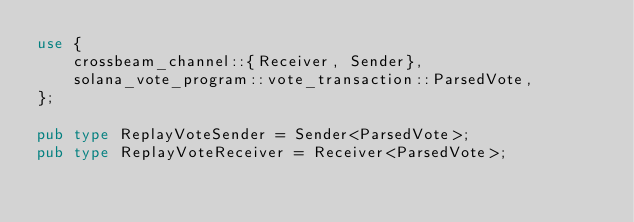<code> <loc_0><loc_0><loc_500><loc_500><_Rust_>use {
    crossbeam_channel::{Receiver, Sender},
    solana_vote_program::vote_transaction::ParsedVote,
};

pub type ReplayVoteSender = Sender<ParsedVote>;
pub type ReplayVoteReceiver = Receiver<ParsedVote>;
</code> 